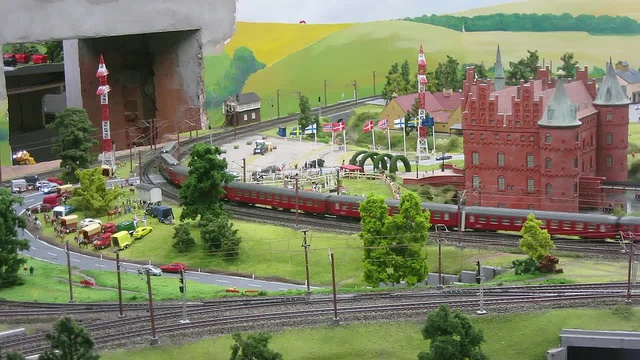Describe the objects in this image and their specific colors. I can see train in darkgray, maroon, gray, and black tones, car in darkgray, brown, maroon, and olive tones, car in darkgray, maroon, and brown tones, car in darkgray, lightgray, and gray tones, and car in darkgray, khaki, darkgreen, and olive tones in this image. 